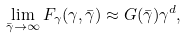<formula> <loc_0><loc_0><loc_500><loc_500>\lim _ { \bar { \gamma } \rightarrow \infty } F _ { \gamma } ( \gamma , \bar { \gamma } ) \approx G ( \bar { \gamma } ) \gamma ^ { d } ,</formula> 